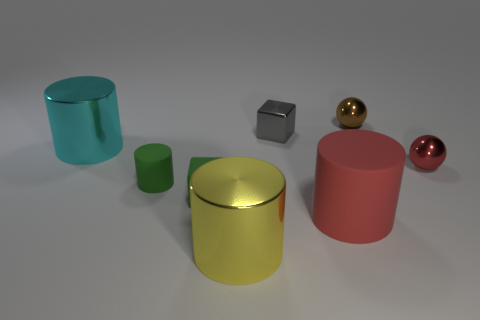There is a brown thing that is made of the same material as the small red sphere; what is its size?
Your answer should be compact. Small. How many green objects are tiny objects or shiny blocks?
Offer a terse response. 2. What is the shape of the object that is the same color as the tiny matte cube?
Make the answer very short. Cylinder. Is there anything else that has the same material as the yellow cylinder?
Keep it short and to the point. Yes. Does the rubber object on the right side of the gray object have the same shape as the large metallic object that is left of the big yellow metal thing?
Make the answer very short. Yes. How many yellow shiny things are there?
Your response must be concise. 1. What is the shape of the yellow object that is made of the same material as the tiny brown ball?
Make the answer very short. Cylinder. Are there any other things of the same color as the shiny cube?
Keep it short and to the point. No. There is a rubber block; does it have the same color as the large thing behind the rubber cube?
Give a very brief answer. No. Are there fewer red objects that are behind the small brown metallic object than small shiny blocks?
Offer a terse response. Yes. 